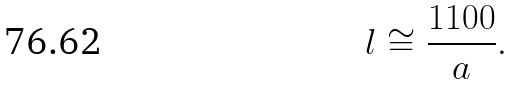Convert formula to latex. <formula><loc_0><loc_0><loc_500><loc_500>l \cong \frac { 1 1 0 0 } { a } .</formula> 